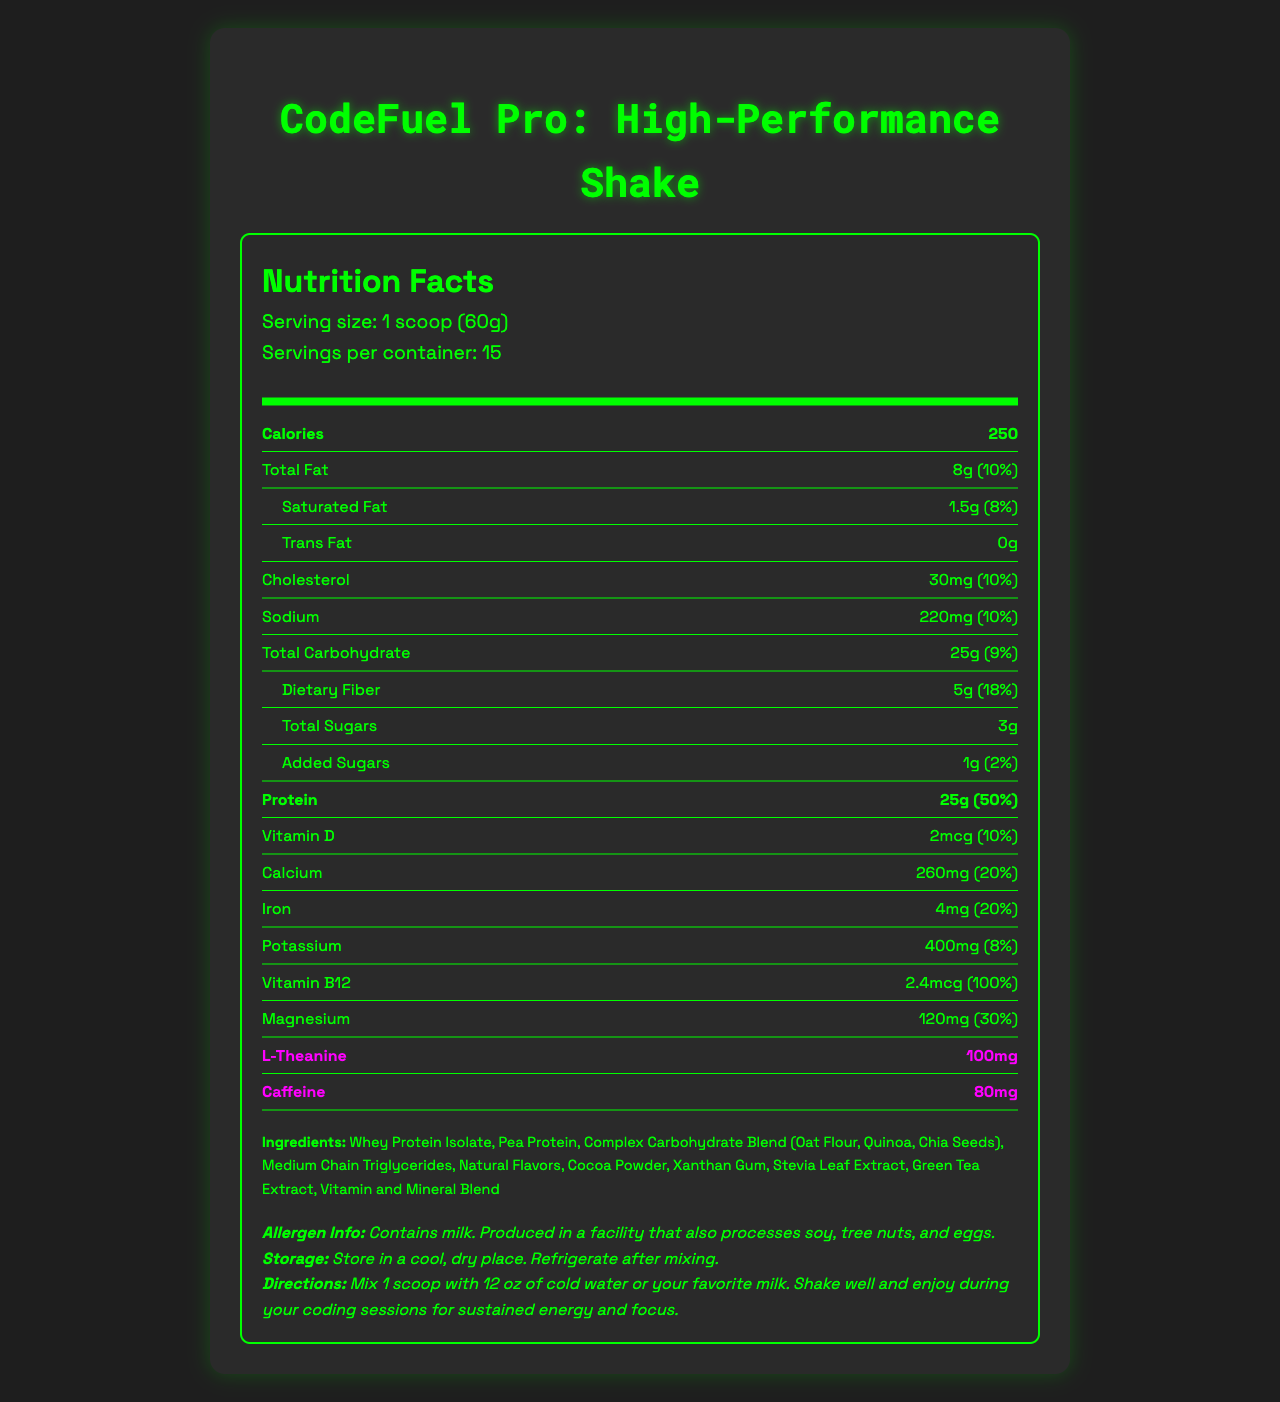what is the serving size of CodeFuel Pro? The serving size is clearly indicated at the beginning of the document as "1 scoop (60g)".
Answer: 1 scoop (60g) how many calories are in one serving? The number of calories is specified in the "Calories" section.
Answer: 250 What is the total amount of protein per serving? The document states that each serving contains 25g of protein.
Answer: 25g How many servings are there per container? The document specifies that there are 15 servings per container.
Answer: 15 What are the ingredients of CodeFuel Pro? The ingredients are listed in the "Ingredients" section towards the end of the document.
Answer: Whey Protein Isolate, Pea Protein, Complex Carbohydrate Blend (Oat Flour, Quinoa, Chia Seeds), Medium Chain Triglycerides, Natural Flavors, Cocoa Powder, Xanthan Gum, Stevia Leaf Extract, Green Tea Extract, Vitamin and Mineral Blend How much caffeine is in one serving? The amount of caffeine is specified in the "highlight" section.
Answer: 80mg What is the daily value percentage of iron? A. 10% B. 20% C. 30% D. 40% The document lists the daily value percentage of iron as 20%.
Answer: B Which nutrient has the highest daily value percentage? A. Dietary Fiber B. Protein C. Vitamin B12 D. Magnesium While Protein has 50%, Vitamin B12 has the highest daily value percentage at 100%.
Answer: C Is there any trans fat in CodeFuel Pro? The document explicitly mentions that there is 0g of trans fat in the shake.
Answer: No What is the allergen information for CodeFuel Pro? The allergen information is clearly listed under the "allergen info" section at the end of the document.
Answer: Contains milk. Produced in a facility that also processes soy, tree nuts, and eggs. Summarize the main purpose of CodeFuel Pro. The document outlines that the shake is formulated to support long coding sessions with high protein content and other nutrients aimed at maintaining energy and focus.
Answer: CodeFuel Pro is a high-performance meal replacement shake designed for sustained energy and focus during long coding sessions. It provides an optimal balance of protein, carbohydrates, and key vitamins and minerals, including L-theanine and caffeine, to enhance cognitive performance. What is the exact amount of vitamin E in the shake? The document does not provide information about Vitamin E content.
Answer: Cannot be determined How much added sugar is in one serving? The document lists the added sugars amount under the carbohydrate section.
Answer: 1g What are the storage instructions for CodeFuel Pro? The storage instructions are provided towards the end of the document.
Answer: Store in a cool, dry place. Refrigerate after mixing. Which carbohydrate sources are included in the shake? The document lists these carbohydrate sources under the ingredients section as part of the "Complex Carbohydrate Blend".
Answer: Oat Flour, Quinoa, Chia Seeds What is the recommended mixing instruction for CodeFuel Pro? The directions for use are specified in the instructions section at the end of the document.
Answer: Mix 1 scoop with 12 oz of cold water or your favorite milk. Shake well and enjoy during your coding sessions for sustained energy and focus. 